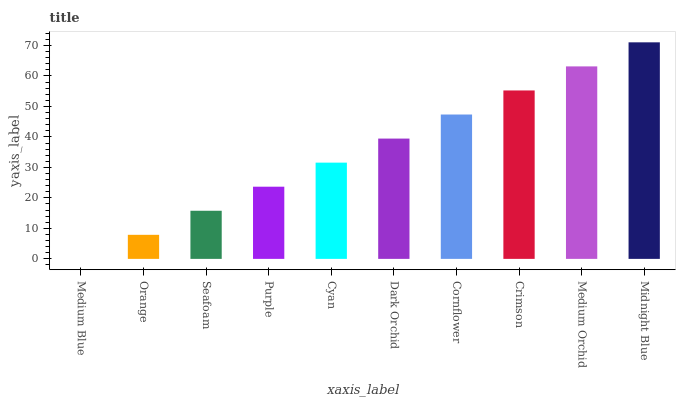Is Medium Blue the minimum?
Answer yes or no. Yes. Is Midnight Blue the maximum?
Answer yes or no. Yes. Is Orange the minimum?
Answer yes or no. No. Is Orange the maximum?
Answer yes or no. No. Is Orange greater than Medium Blue?
Answer yes or no. Yes. Is Medium Blue less than Orange?
Answer yes or no. Yes. Is Medium Blue greater than Orange?
Answer yes or no. No. Is Orange less than Medium Blue?
Answer yes or no. No. Is Dark Orchid the high median?
Answer yes or no. Yes. Is Cyan the low median?
Answer yes or no. Yes. Is Purple the high median?
Answer yes or no. No. Is Cornflower the low median?
Answer yes or no. No. 